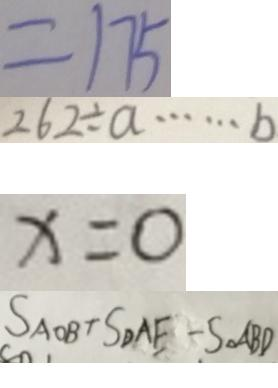<formula> <loc_0><loc_0><loc_500><loc_500>= 1 7 5 
 2 6 2 \div a \cdots b 
 x = 0 
 S _ { A O B } + S _ { D A E } - S _ { \Delta } A B D</formula> 